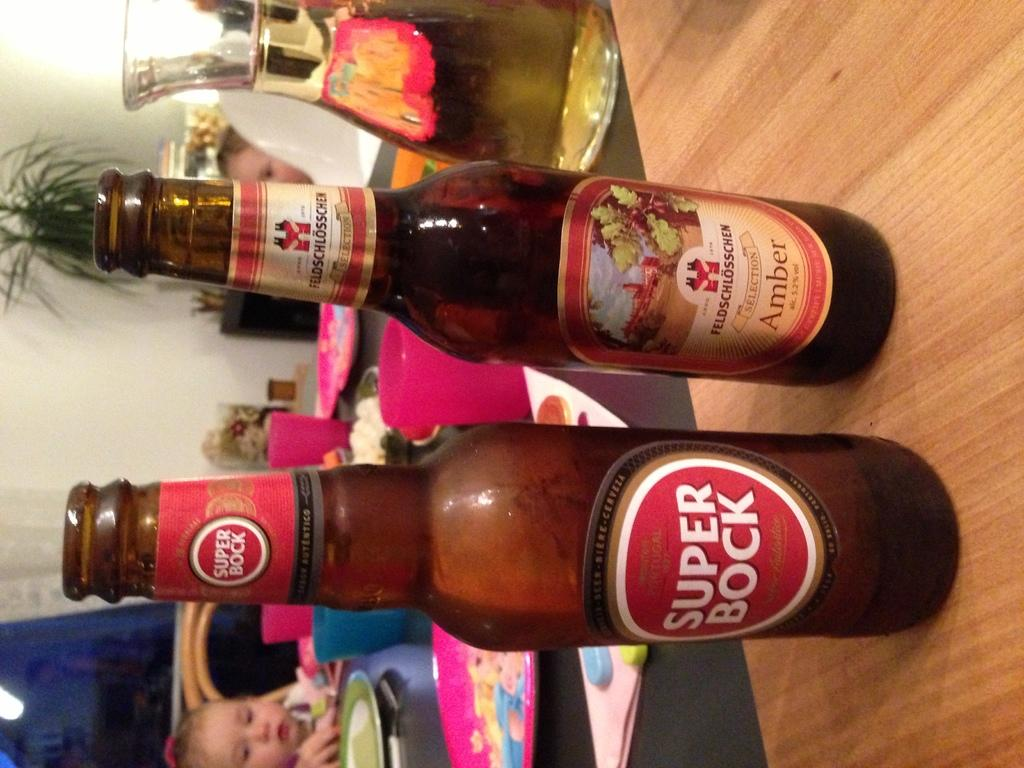<image>
Summarize the visual content of the image. A bottle of Super Bock sits next to another bottle. 